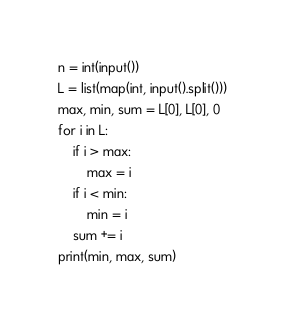<code> <loc_0><loc_0><loc_500><loc_500><_Python_>n = int(input())
L = list(map(int, input().split()))
max, min, sum = L[0], L[0], 0
for i in L:
    if i > max:
        max = i
    if i < min:
        min = i
    sum += i
print(min, max, sum)
</code> 